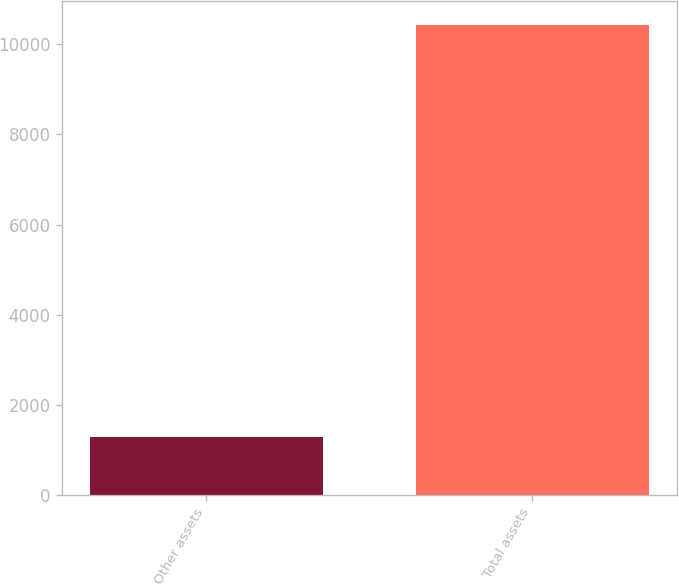<chart> <loc_0><loc_0><loc_500><loc_500><bar_chart><fcel>Other assets<fcel>Total assets<nl><fcel>1281<fcel>10435<nl></chart> 